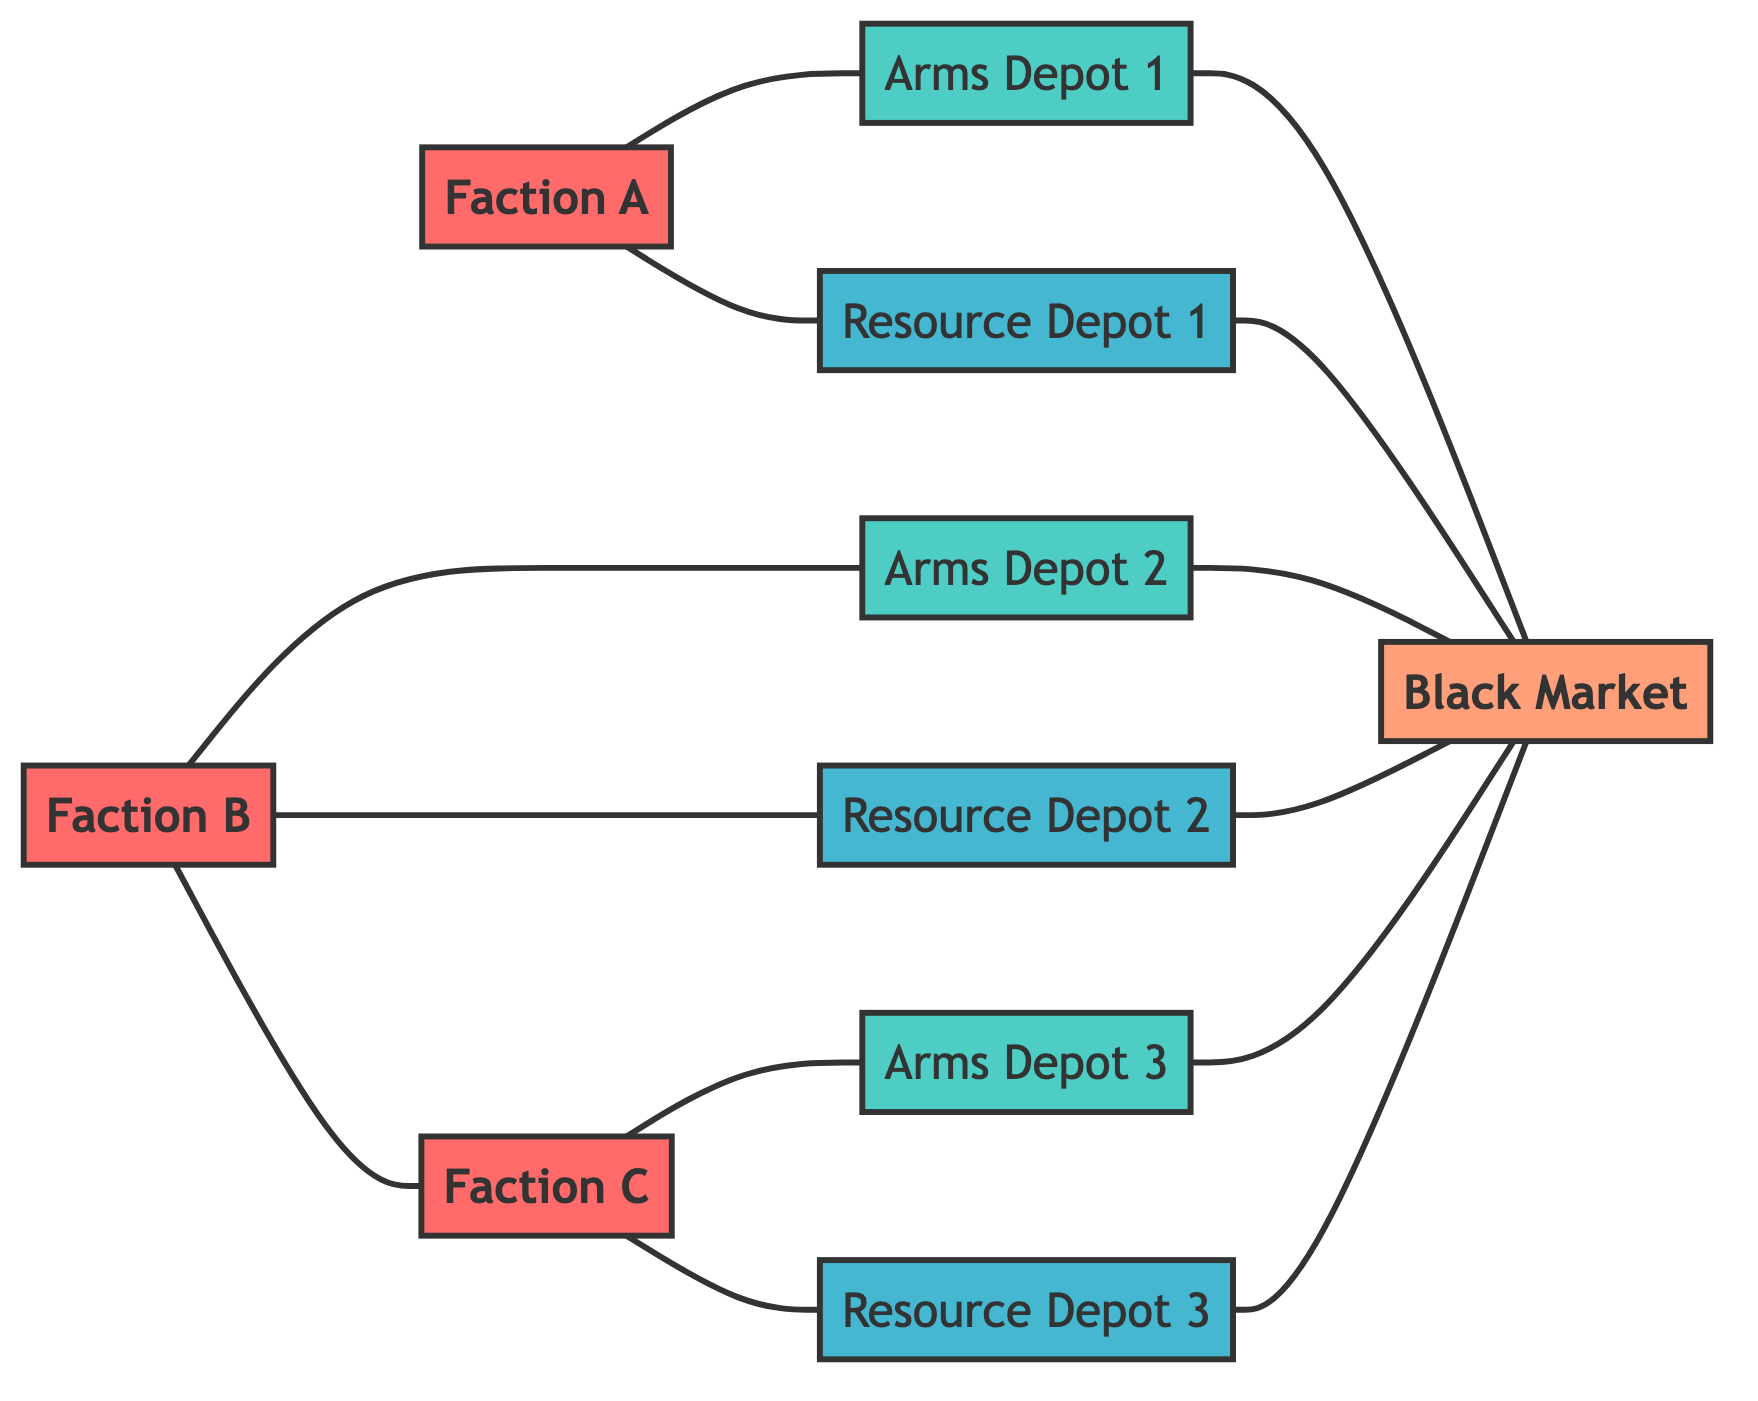What is the total number of factions in the diagram? The diagram lists three factions: Faction A, Faction B, and Faction C. By counting each distinct faction node, we arrive at a total of three factions.
Answer: 3 Which faction collaborates with Faction B? The diagram shows an edge connecting Faction B with Faction C. This indicates that Faction B collaborates with Faction C.
Answer: Faction C How many arms depots are connected to Faction A? Faction A is directly connected to one arms depot: Arms Depot 1. We verify this by looking for edges originating from Faction A specifically pointing to arms depots.
Answer: 1 What is the relationship between Resource Depot 2 and the Black Market? The diagram shows an edge directly connecting Resource Depot 2 to the Black Market, indicating a direct relationship or route. Therefore, they are connected.
Answer: Connected How many total nodes are present in this diagram? The diagram consists of ten nodes: three factions, three arms depots, three resource depots, and one black market. By counting all these nodes, we confirm there are ten in total.
Answer: 10 What is the primary way Faction C acquires its weapons? Faction C obtains its weapons directly from Arms Depot 3 as indicated by their connection. There is no other route provided in the diagram for acquiring weapons.
Answer: Arms Depot 3 Are there any depots that link resources directly to the Black Market? Yes, the diagram indicates that all three resource depots (Resource Depot 1, Resource Depot 2, Resource Depot 3) are connected to the Black Market, establishing direct links for resource flow.
Answer: Yes Which arms depot does Faction A use? Faction A uses Arms Depot 1, as indicated by the edge connecting them in the diagram.
Answer: Arms Depot 1 What is the total number of edges connected to the Black Market? The Black Market has six edges connecting it to three arms depots and three resource depots. This is confirmed by counting the edges prominently linked to the Black Market.
Answer: 6 